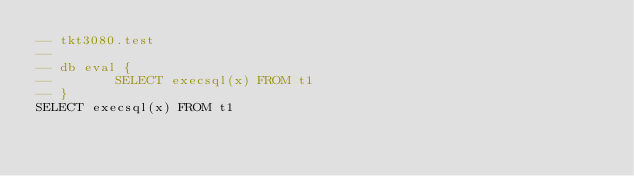<code> <loc_0><loc_0><loc_500><loc_500><_SQL_>-- tkt3080.test
-- 
-- db eval {
--        SELECT execsql(x) FROM t1
-- }
SELECT execsql(x) FROM t1</code> 